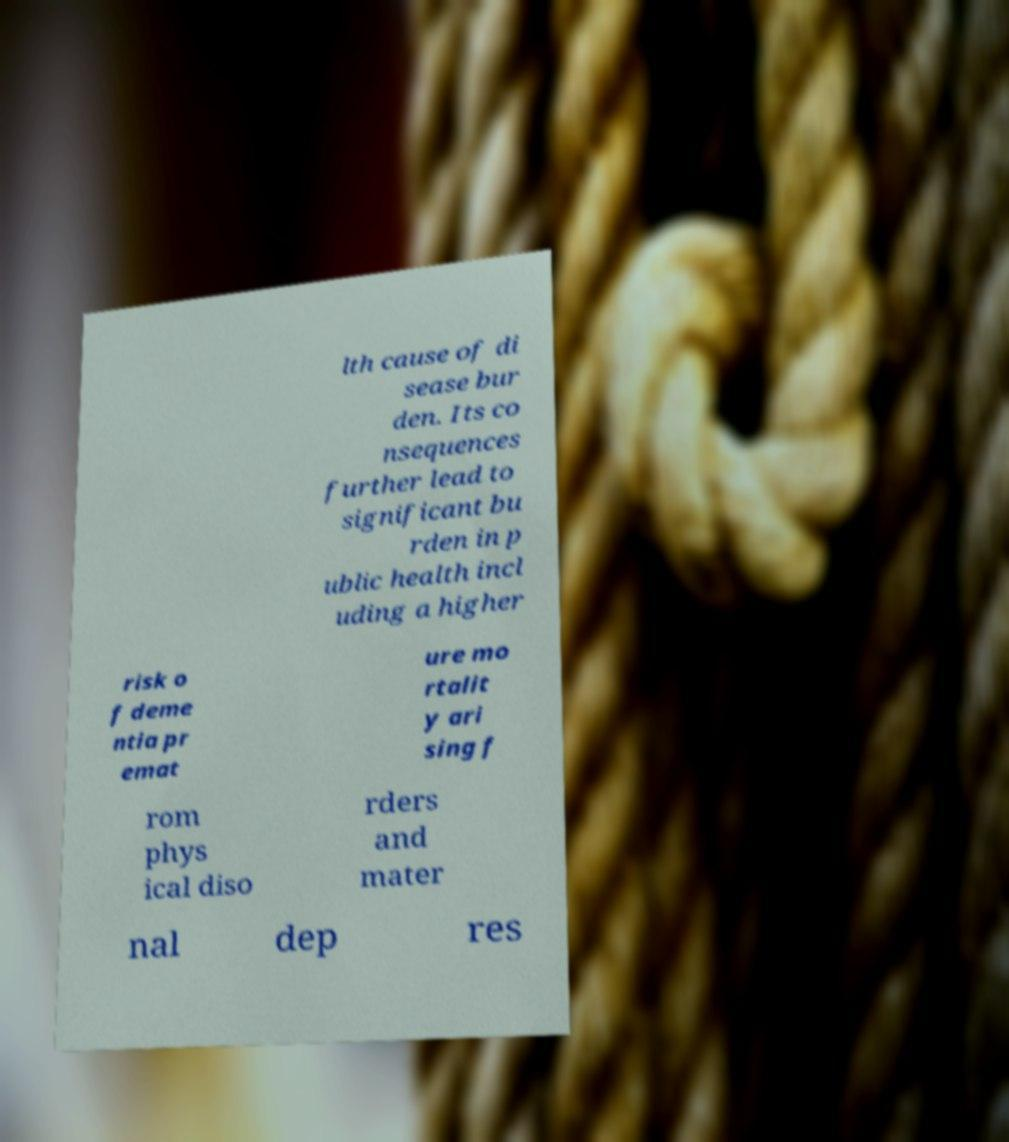What messages or text are displayed in this image? I need them in a readable, typed format. lth cause of di sease bur den. Its co nsequences further lead to significant bu rden in p ublic health incl uding a higher risk o f deme ntia pr emat ure mo rtalit y ari sing f rom phys ical diso rders and mater nal dep res 